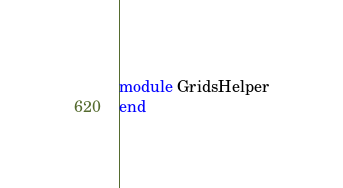Convert code to text. <code><loc_0><loc_0><loc_500><loc_500><_Ruby_>module GridsHelper
end
</code> 